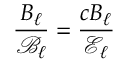<formula> <loc_0><loc_0><loc_500><loc_500>\frac { B _ { \ell } } { \mathcal { B } _ { \ell } } = \frac { c B _ { \ell } } { \mathcal { E } _ { \ell } }</formula> 